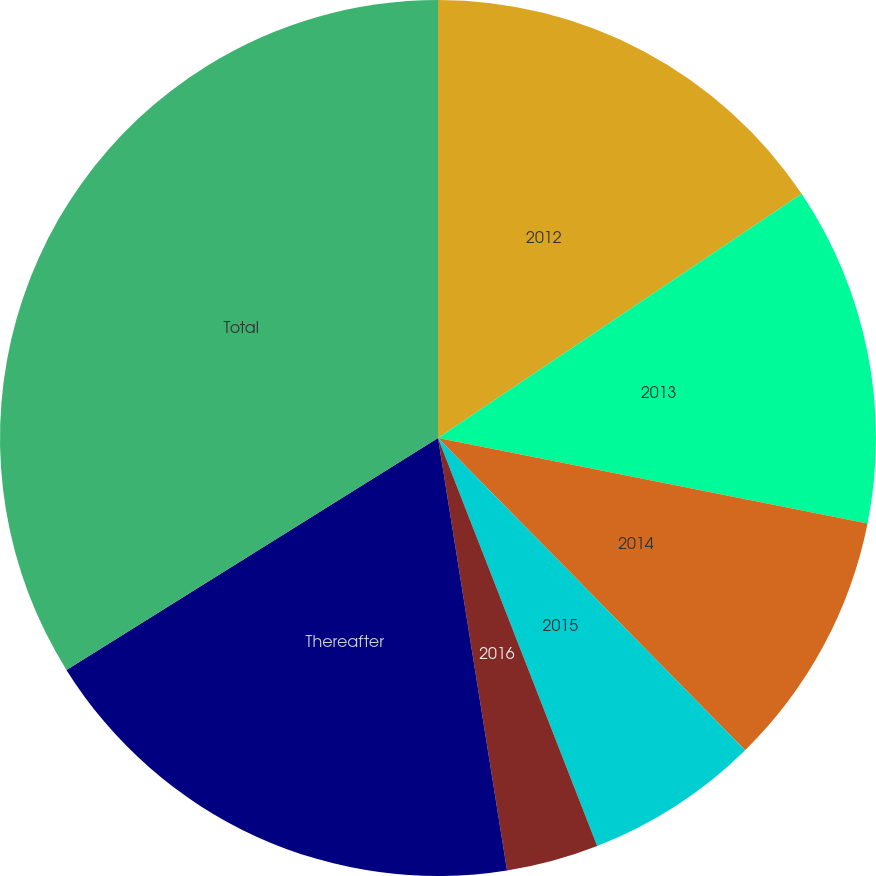<chart> <loc_0><loc_0><loc_500><loc_500><pie_chart><fcel>2012<fcel>2013<fcel>2014<fcel>2015<fcel>2016<fcel>Thereafter<fcel>Total<nl><fcel>15.59%<fcel>12.54%<fcel>9.5%<fcel>6.45%<fcel>3.4%<fcel>18.64%<fcel>33.88%<nl></chart> 